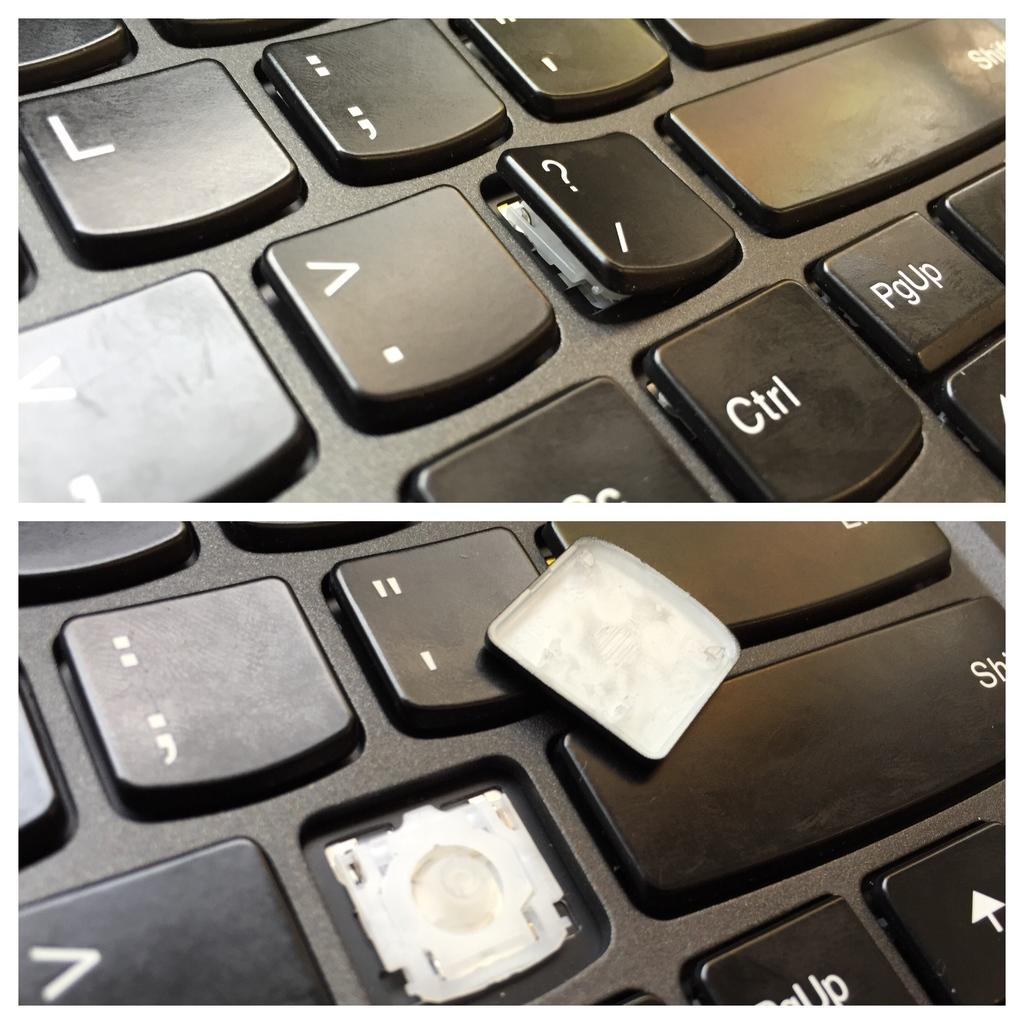<image>
Provide a brief description of the given image. A black keyboard has broken keys and one of them says Shift. 